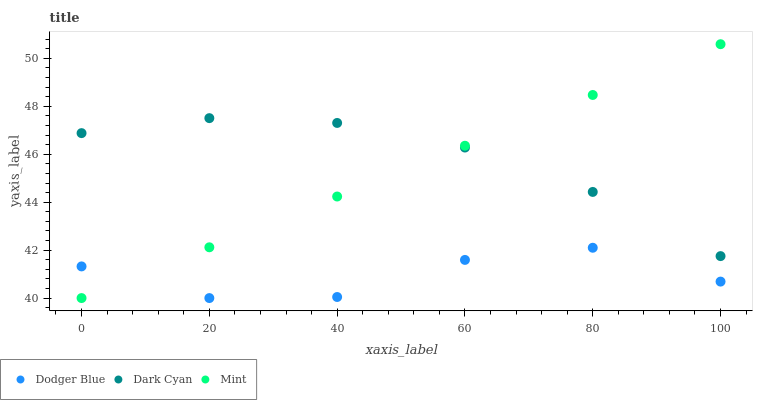Does Dodger Blue have the minimum area under the curve?
Answer yes or no. Yes. Does Dark Cyan have the maximum area under the curve?
Answer yes or no. Yes. Does Mint have the minimum area under the curve?
Answer yes or no. No. Does Mint have the maximum area under the curve?
Answer yes or no. No. Is Mint the smoothest?
Answer yes or no. Yes. Is Dodger Blue the roughest?
Answer yes or no. Yes. Is Dodger Blue the smoothest?
Answer yes or no. No. Is Mint the roughest?
Answer yes or no. No. Does Mint have the lowest value?
Answer yes or no. Yes. Does Mint have the highest value?
Answer yes or no. Yes. Does Dodger Blue have the highest value?
Answer yes or no. No. Is Dodger Blue less than Dark Cyan?
Answer yes or no. Yes. Is Dark Cyan greater than Dodger Blue?
Answer yes or no. Yes. Does Dodger Blue intersect Mint?
Answer yes or no. Yes. Is Dodger Blue less than Mint?
Answer yes or no. No. Is Dodger Blue greater than Mint?
Answer yes or no. No. Does Dodger Blue intersect Dark Cyan?
Answer yes or no. No. 